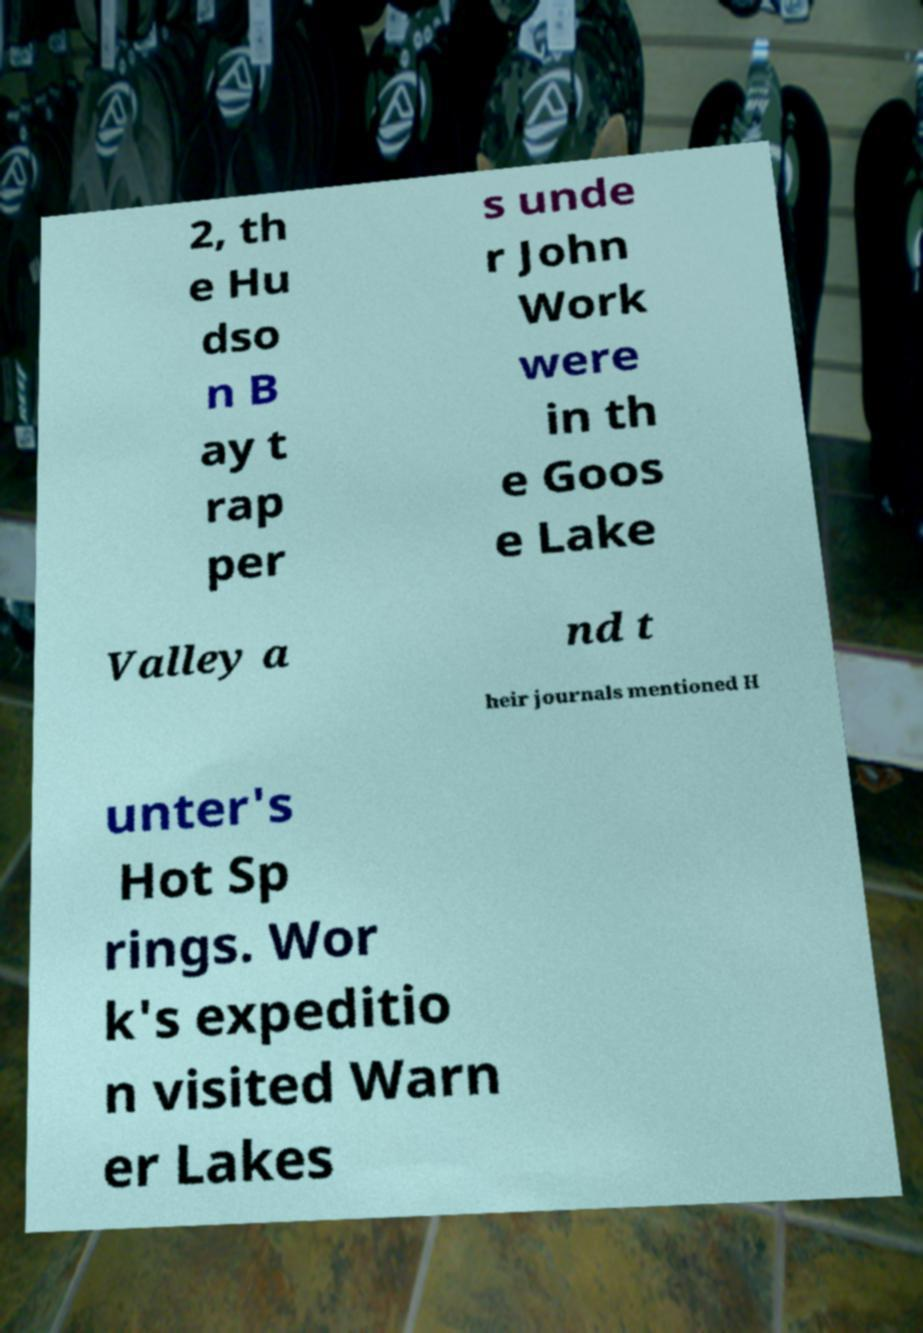Could you extract and type out the text from this image? 2, th e Hu dso n B ay t rap per s unde r John Work were in th e Goos e Lake Valley a nd t heir journals mentioned H unter's Hot Sp rings. Wor k's expeditio n visited Warn er Lakes 